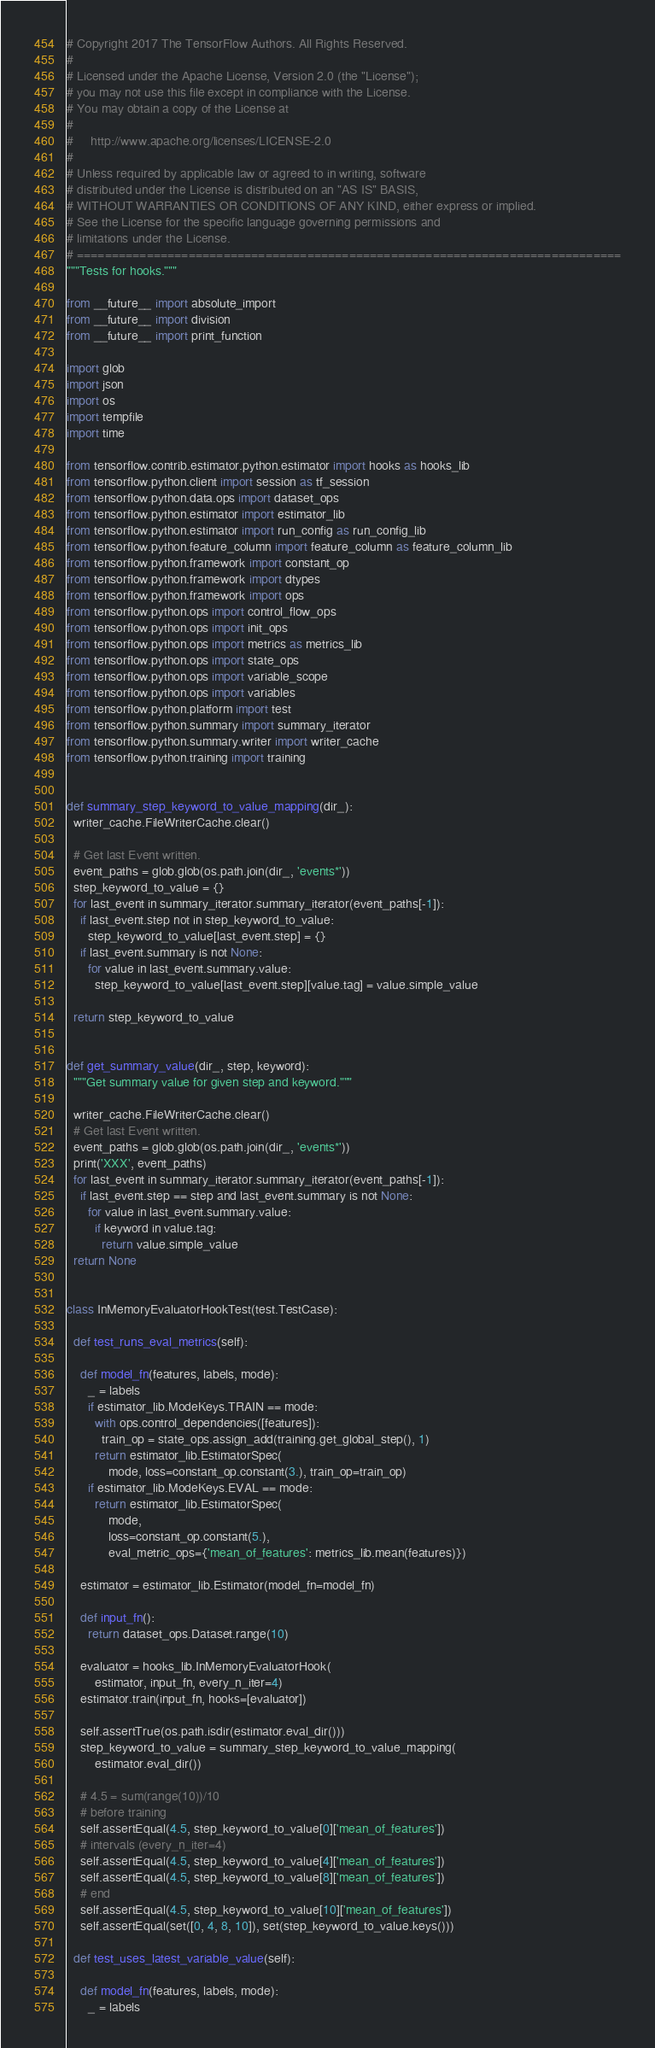<code> <loc_0><loc_0><loc_500><loc_500><_Python_># Copyright 2017 The TensorFlow Authors. All Rights Reserved.
#
# Licensed under the Apache License, Version 2.0 (the "License");
# you may not use this file except in compliance with the License.
# You may obtain a copy of the License at
#
#     http://www.apache.org/licenses/LICENSE-2.0
#
# Unless required by applicable law or agreed to in writing, software
# distributed under the License is distributed on an "AS IS" BASIS,
# WITHOUT WARRANTIES OR CONDITIONS OF ANY KIND, either express or implied.
# See the License for the specific language governing permissions and
# limitations under the License.
# ==============================================================================
"""Tests for hooks."""

from __future__ import absolute_import
from __future__ import division
from __future__ import print_function

import glob
import json
import os
import tempfile
import time

from tensorflow.contrib.estimator.python.estimator import hooks as hooks_lib
from tensorflow.python.client import session as tf_session
from tensorflow.python.data.ops import dataset_ops
from tensorflow.python.estimator import estimator_lib
from tensorflow.python.estimator import run_config as run_config_lib
from tensorflow.python.feature_column import feature_column as feature_column_lib
from tensorflow.python.framework import constant_op
from tensorflow.python.framework import dtypes
from tensorflow.python.framework import ops
from tensorflow.python.ops import control_flow_ops
from tensorflow.python.ops import init_ops
from tensorflow.python.ops import metrics as metrics_lib
from tensorflow.python.ops import state_ops
from tensorflow.python.ops import variable_scope
from tensorflow.python.ops import variables
from tensorflow.python.platform import test
from tensorflow.python.summary import summary_iterator
from tensorflow.python.summary.writer import writer_cache
from tensorflow.python.training import training


def summary_step_keyword_to_value_mapping(dir_):
  writer_cache.FileWriterCache.clear()

  # Get last Event written.
  event_paths = glob.glob(os.path.join(dir_, 'events*'))
  step_keyword_to_value = {}
  for last_event in summary_iterator.summary_iterator(event_paths[-1]):
    if last_event.step not in step_keyword_to_value:
      step_keyword_to_value[last_event.step] = {}
    if last_event.summary is not None:
      for value in last_event.summary.value:
        step_keyword_to_value[last_event.step][value.tag] = value.simple_value

  return step_keyword_to_value


def get_summary_value(dir_, step, keyword):
  """Get summary value for given step and keyword."""

  writer_cache.FileWriterCache.clear()
  # Get last Event written.
  event_paths = glob.glob(os.path.join(dir_, 'events*'))
  print('XXX', event_paths)
  for last_event in summary_iterator.summary_iterator(event_paths[-1]):
    if last_event.step == step and last_event.summary is not None:
      for value in last_event.summary.value:
        if keyword in value.tag:
          return value.simple_value
  return None


class InMemoryEvaluatorHookTest(test.TestCase):

  def test_runs_eval_metrics(self):

    def model_fn(features, labels, mode):
      _ = labels
      if estimator_lib.ModeKeys.TRAIN == mode:
        with ops.control_dependencies([features]):
          train_op = state_ops.assign_add(training.get_global_step(), 1)
        return estimator_lib.EstimatorSpec(
            mode, loss=constant_op.constant(3.), train_op=train_op)
      if estimator_lib.ModeKeys.EVAL == mode:
        return estimator_lib.EstimatorSpec(
            mode,
            loss=constant_op.constant(5.),
            eval_metric_ops={'mean_of_features': metrics_lib.mean(features)})

    estimator = estimator_lib.Estimator(model_fn=model_fn)

    def input_fn():
      return dataset_ops.Dataset.range(10)

    evaluator = hooks_lib.InMemoryEvaluatorHook(
        estimator, input_fn, every_n_iter=4)
    estimator.train(input_fn, hooks=[evaluator])

    self.assertTrue(os.path.isdir(estimator.eval_dir()))
    step_keyword_to_value = summary_step_keyword_to_value_mapping(
        estimator.eval_dir())

    # 4.5 = sum(range(10))/10
    # before training
    self.assertEqual(4.5, step_keyword_to_value[0]['mean_of_features'])
    # intervals (every_n_iter=4)
    self.assertEqual(4.5, step_keyword_to_value[4]['mean_of_features'])
    self.assertEqual(4.5, step_keyword_to_value[8]['mean_of_features'])
    # end
    self.assertEqual(4.5, step_keyword_to_value[10]['mean_of_features'])
    self.assertEqual(set([0, 4, 8, 10]), set(step_keyword_to_value.keys()))

  def test_uses_latest_variable_value(self):

    def model_fn(features, labels, mode):
      _ = labels</code> 